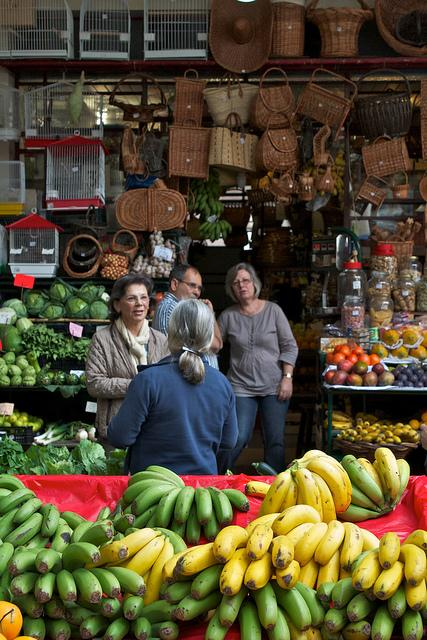What is meant to be kept in those cages? Please explain your reasoning. birds. They are birdcages. 